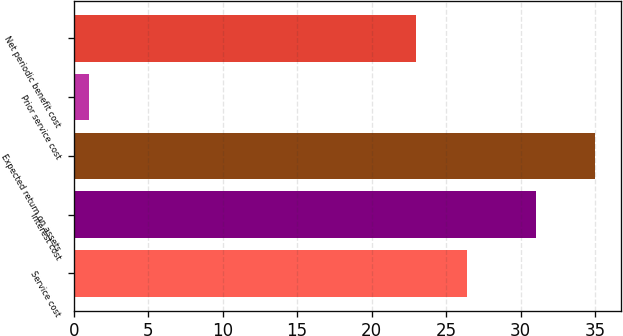Convert chart. <chart><loc_0><loc_0><loc_500><loc_500><bar_chart><fcel>Service cost<fcel>Interest cost<fcel>Expected return on assets<fcel>Prior service cost<fcel>Net periodic benefit cost<nl><fcel>26.4<fcel>31<fcel>35<fcel>1<fcel>23<nl></chart> 